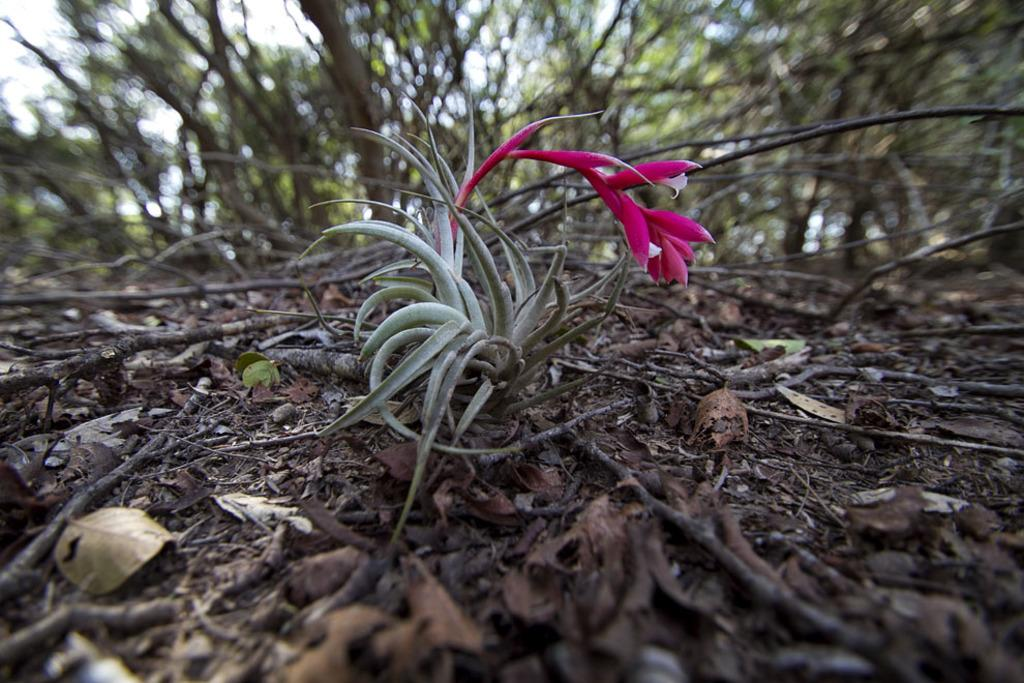What type of vegetation is predominant in the image? There are many trees in the image. Can you describe any specific flora in the image? There is a flower on a plant in the image. What else can be found on the ground in the image? There are twigs on the ground in the image. What type of silk material is draped over the trees in the image? There is no silk material present in the image; it features trees, a flower on a plant, and twigs on the ground. 